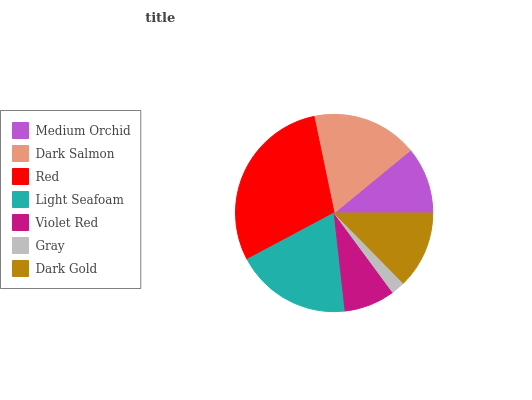Is Gray the minimum?
Answer yes or no. Yes. Is Red the maximum?
Answer yes or no. Yes. Is Dark Salmon the minimum?
Answer yes or no. No. Is Dark Salmon the maximum?
Answer yes or no. No. Is Dark Salmon greater than Medium Orchid?
Answer yes or no. Yes. Is Medium Orchid less than Dark Salmon?
Answer yes or no. Yes. Is Medium Orchid greater than Dark Salmon?
Answer yes or no. No. Is Dark Salmon less than Medium Orchid?
Answer yes or no. No. Is Dark Gold the high median?
Answer yes or no. Yes. Is Dark Gold the low median?
Answer yes or no. Yes. Is Gray the high median?
Answer yes or no. No. Is Gray the low median?
Answer yes or no. No. 